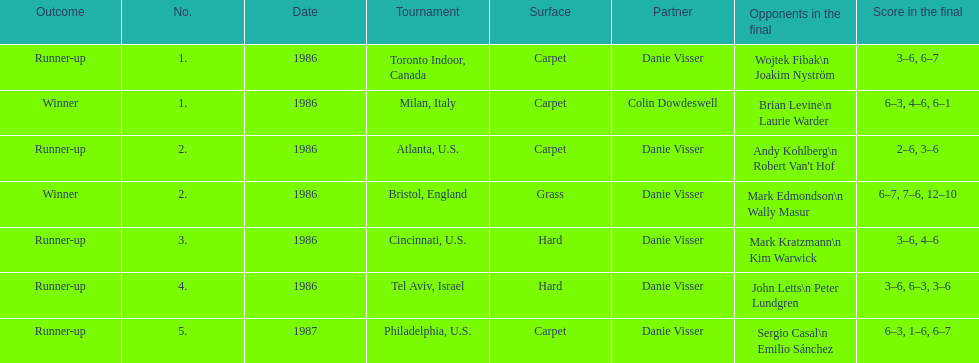Can you identify the partner listed last? Danie Visser. 